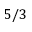Convert formula to latex. <formula><loc_0><loc_0><loc_500><loc_500>5 / 3</formula> 